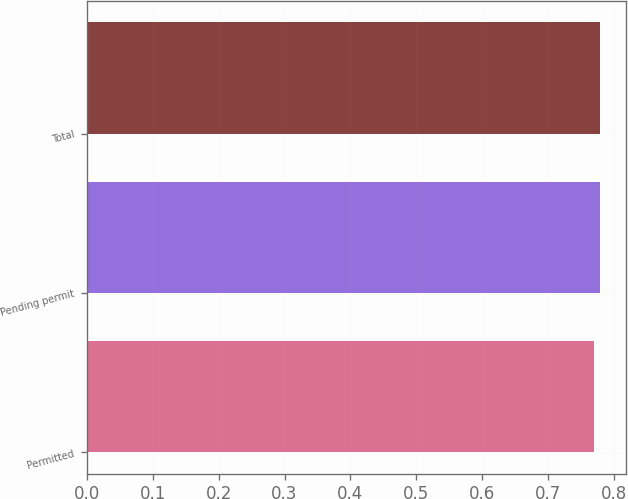Convert chart to OTSL. <chart><loc_0><loc_0><loc_500><loc_500><bar_chart><fcel>Permitted<fcel>Pending permit<fcel>Total<nl><fcel>0.77<fcel>0.78<fcel>0.78<nl></chart> 